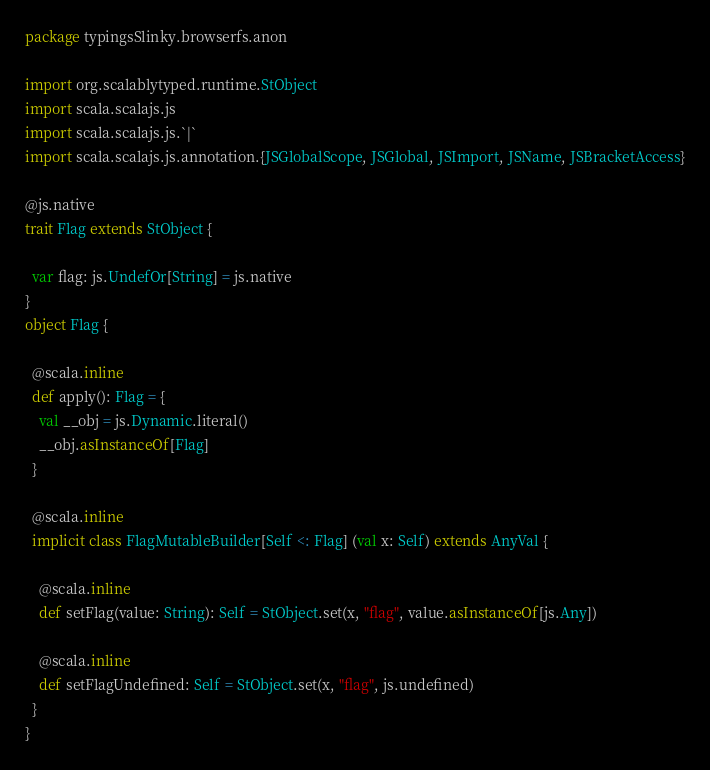<code> <loc_0><loc_0><loc_500><loc_500><_Scala_>package typingsSlinky.browserfs.anon

import org.scalablytyped.runtime.StObject
import scala.scalajs.js
import scala.scalajs.js.`|`
import scala.scalajs.js.annotation.{JSGlobalScope, JSGlobal, JSImport, JSName, JSBracketAccess}

@js.native
trait Flag extends StObject {
  
  var flag: js.UndefOr[String] = js.native
}
object Flag {
  
  @scala.inline
  def apply(): Flag = {
    val __obj = js.Dynamic.literal()
    __obj.asInstanceOf[Flag]
  }
  
  @scala.inline
  implicit class FlagMutableBuilder[Self <: Flag] (val x: Self) extends AnyVal {
    
    @scala.inline
    def setFlag(value: String): Self = StObject.set(x, "flag", value.asInstanceOf[js.Any])
    
    @scala.inline
    def setFlagUndefined: Self = StObject.set(x, "flag", js.undefined)
  }
}
</code> 